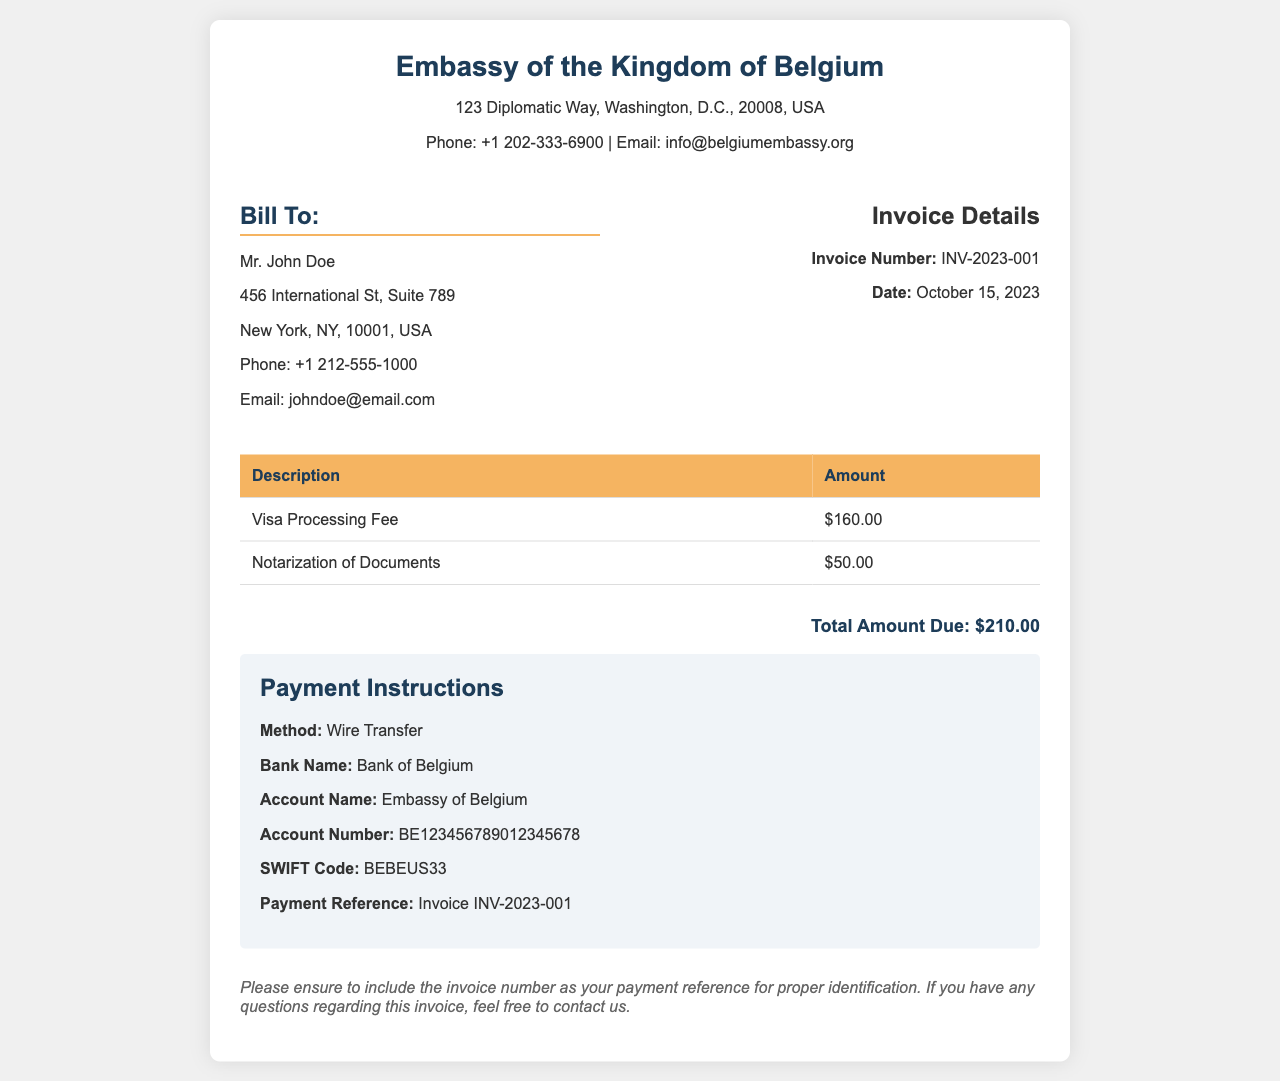What is the total amount due? The total amount due is clearly stated in the document as the sum of the fees listed in the table.
Answer: $210.00 What is the visa processing fee? The visa processing fee is specified in the invoice details as one of the services rendered.
Answer: $160.00 When was the invoice issued? The date of the invoice is provided in the invoice details section.
Answer: October 15, 2023 Who is the invoice billed to? The home address and name of the person being billed are included in the "Bill To" section.
Answer: Mr. John Doe What is the SWIFT code for the bank? The SWIFT code necessary for wire transfers is detailed under the payment instructions.
Answer: BEBEUS33 What is the payment method specified? The document outlines the method to pay the invoice.
Answer: Wire Transfer What is the account number for the embassy? The account number is provided in the payment instructions section for the payment.
Answer: BE123456789012345678 What title does the header of the document have? The title indicates the type of document being generated regarding consular fees.
Answer: Consular Services Invoice What should be included as the payment reference? The document specifies what must be referenced during the payment process for identification.
Answer: Invoice INV-2023-001 